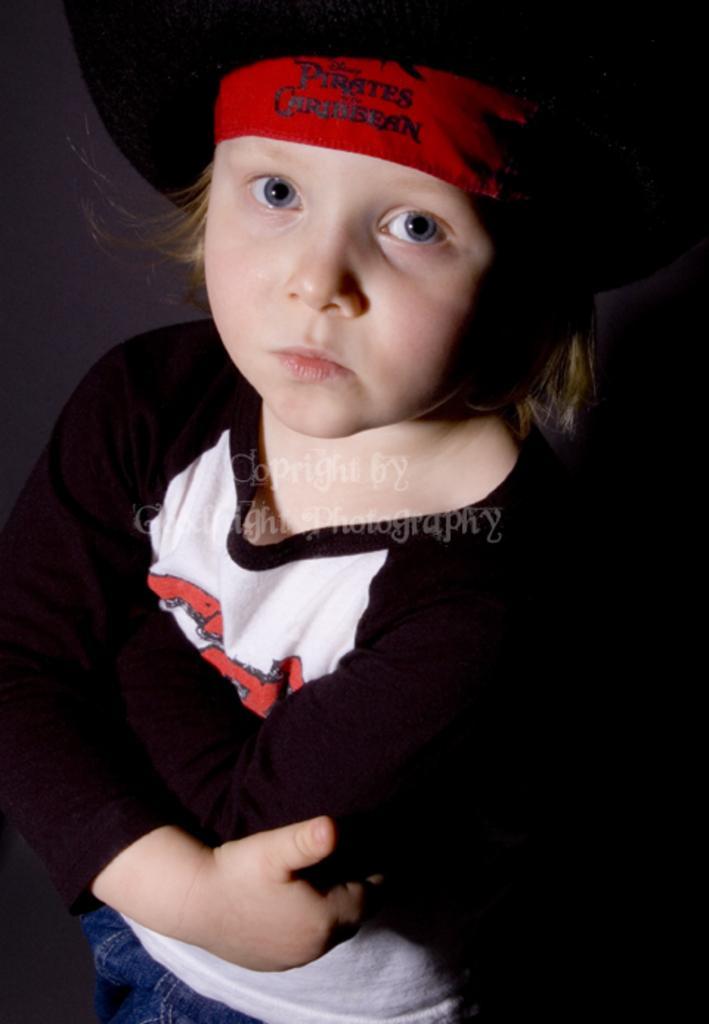Please provide a concise description of this image. In this image I can see a child wearing black and white colored dress and black and red colored hat is standing. I can see the black colored background. 